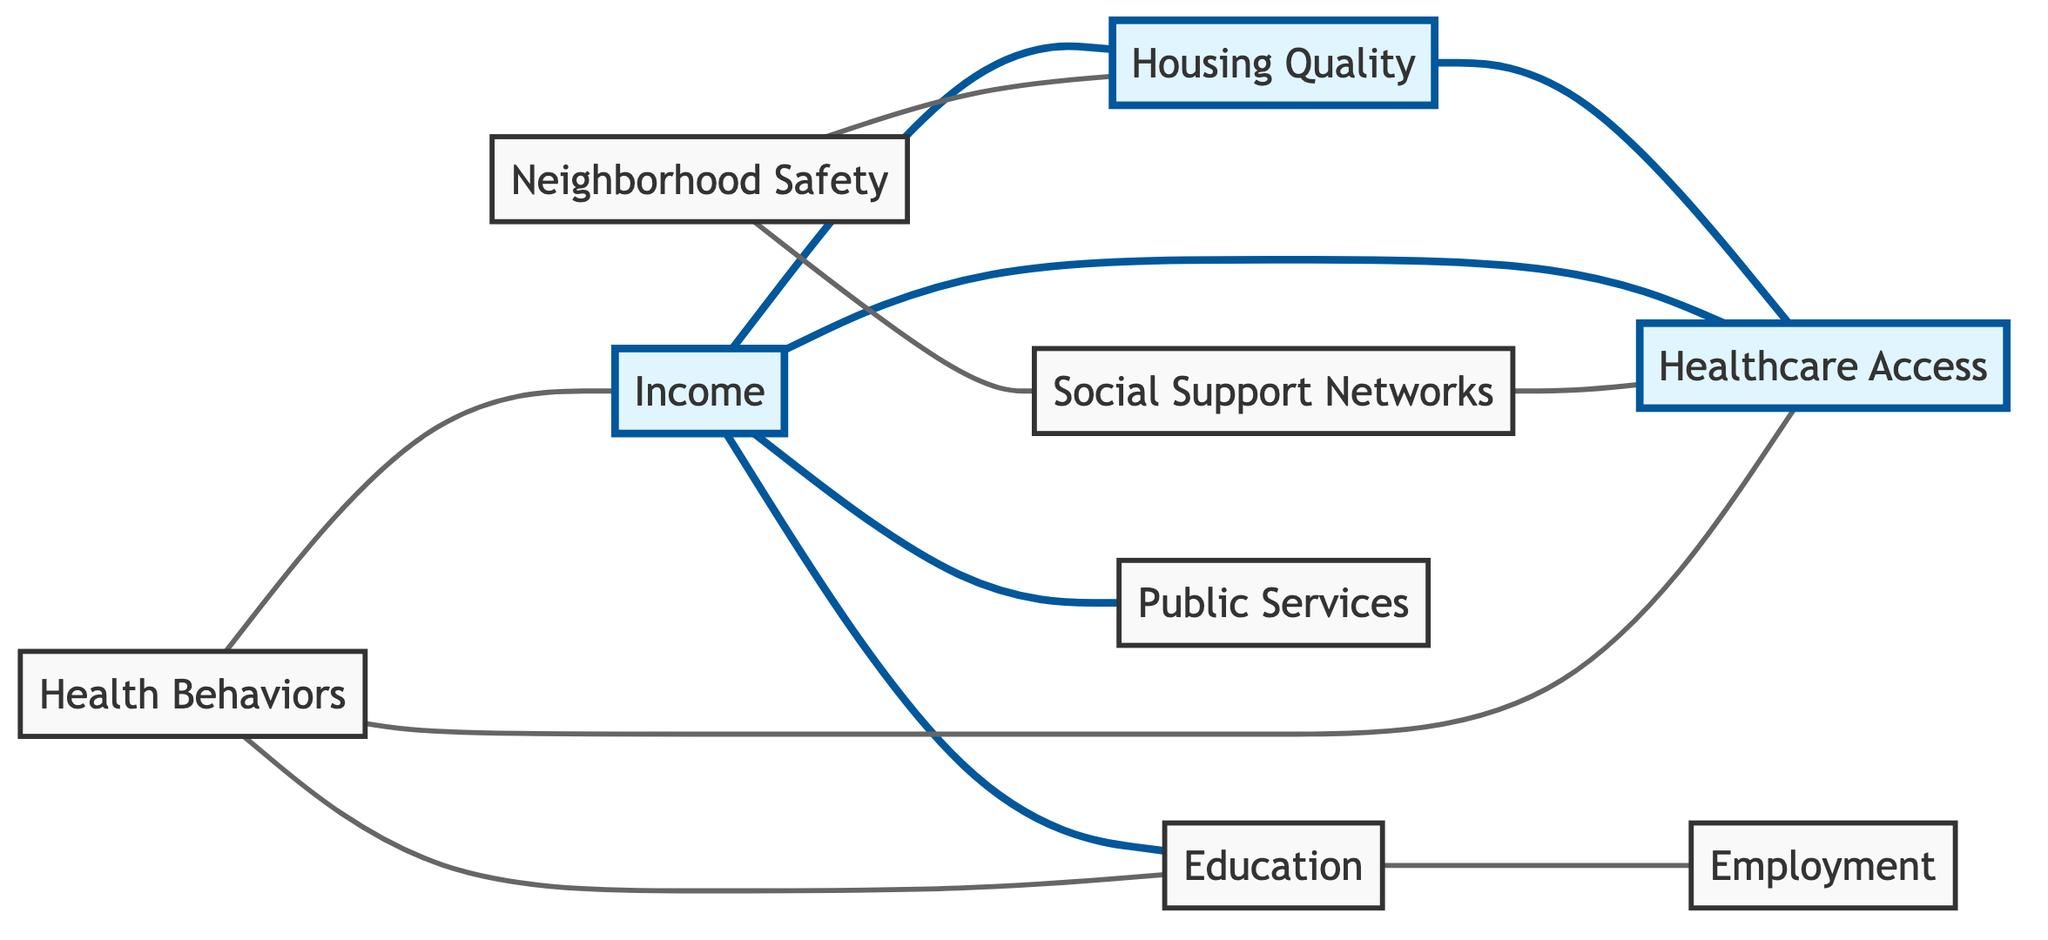What are the total number of nodes in the graph? The diagram contains a list of distinct elements called nodes, which can be counted. There are 9 unique nodes in total: Housing Quality, Employment, Education, Healthcare Access, Social Support Networks, Health Behaviors, Income, Neighborhood Safety, and Public Services.
Answer: 9 How many edges connect to the node 'income'? The edges in the graph represent the relationships between nodes. By examining the connections involving the 'income' node, we can count the direct edges: it connects to Housing Quality, Healthcare Access, Education, and Public Services. This gives us 4 connections (edges).
Answer: 4 What is the relationship between 'neighborhood safety' and 'social support networks'? The relationship can be determined by observing the connecting edge between the two nodes. There is an edge that directly links 'neighborhood safety' and 'social support networks', indicating they influence each other.
Answer: Connected Which nodes are directly connected to 'healthcare access'? To answer this question, we can look for edges that originate from or terminate at 'healthcare access'. The nodes connected are: Housing Quality, Income, Social Support Networks, and Health Behaviors.
Answer: Housing Quality, Income, Social Support Networks, Health Behaviors Is there a pathway in the graph that connects 'education' to 'healthcare access'? To establish whether a pathway exists, we trace the edges: 'education' connects to 'employment', but there’s no direct or indirect link from 'education' to 'healthcare access'. Thus, it is concluded that there is no connection.
Answer: No Which social determinant has the most connections? Counting the edges for each node indicates their interconnectedness; 'income' has connections to four nodes: Housing Quality, Healthcare Access, Education, and Public Services. This makes 'income' the most connected node.
Answer: Income If 'housing quality' improves, which direct nodes would likely be affected? Improvements in 'housing quality' could directly influence nodes it is connected to: healthcare access and neighborhood safety. The relationships indicate that better housing quality can lead to better healthcare and safer neighborhoods.
Answer: Healthcare Access, Neighborhood Safety What are the two nodes that are mutually connected? By examining the graph, we identify any pair of nodes with a connecting edge. For example, one such pair is 'neighborhood safety' and 'social support networks', both of which are directly linked.
Answer: Neighborhood Safety, Social Support Networks 